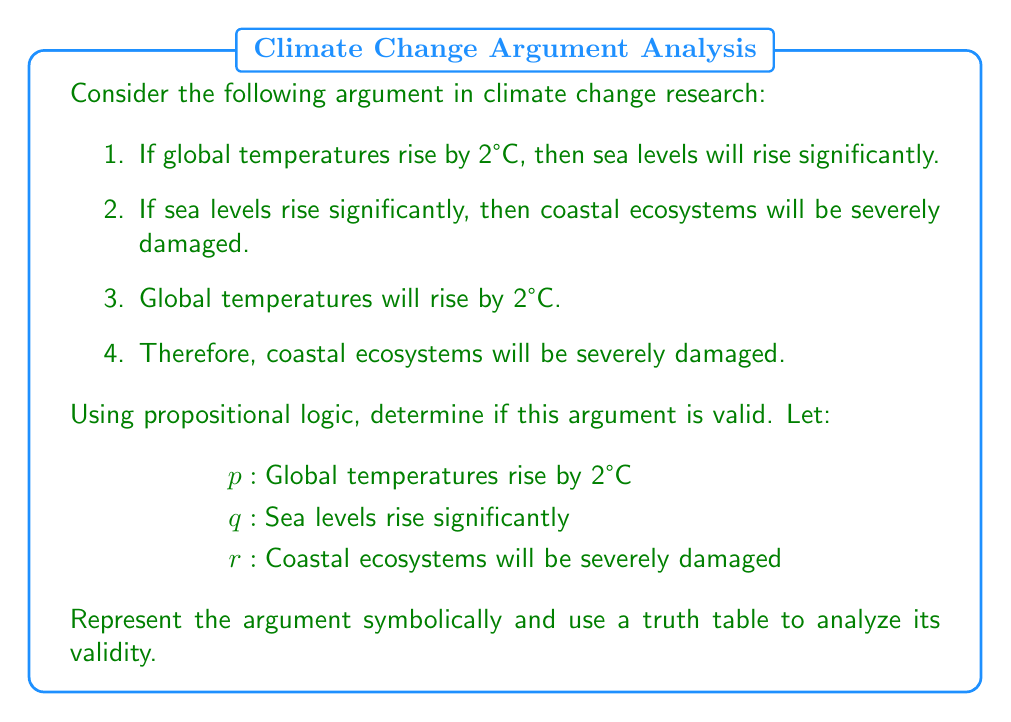Could you help me with this problem? To analyze the validity of this argument using propositional logic, we'll follow these steps:

1. Represent the argument symbolically:
   Premise 1: $p \rightarrow q$
   Premise 2: $q \rightarrow r$
   Premise 3: $p$
   Conclusion: $r$

2. The argument form is:
   $$(p \rightarrow q) \land (q \rightarrow r) \land p \therefore r$$

3. To prove validity, we need to show that whenever all premises are true, the conclusion must also be true. We'll use a truth table to examine all possible combinations:

   $$\begin{array}{|c|c|c|c|c|c|c|}
   \hline
   p & q & r & p \rightarrow q & q \rightarrow r & (p \rightarrow q) \land (q \rightarrow r) \land p & r \\
   \hline
   T & T & T & T & T & T & T \\
   T & T & F & T & F & F & F \\
   T & F & T & F & T & F & T \\
   T & F & F & F & T & F & F \\
   F & T & T & T & T & F & T \\
   F & T & F & T & F & F & F \\
   F & F & T & T & T & F & T \\
   F & F & F & T & T & F & F \\
   \hline
   \end{array}$$

4. Analyze the truth table:
   - The premises are all true only in the first row (where $p$, $q$, and $r$ are all true).
   - In this case, the conclusion ($r$) is also true.
   - There are no rows where all premises are true and the conclusion is false.

5. Logical deduction:
   - Given $p$ is true (Premise 3), and $p \rightarrow q$ (Premise 1), we can conclude $q$ is true (Modus Ponens).
   - Given $q$ is true, and $q \rightarrow r$ (Premise 2), we can conclude $r$ is true (Modus Ponens again).

This logical deduction confirms the validity shown in the truth table.
Answer: The argument is valid. The truth table shows that whenever all premises are true, the conclusion is also true. Additionally, the logical deduction using Modus Ponens twice confirms that the conclusion necessarily follows from the premises. 